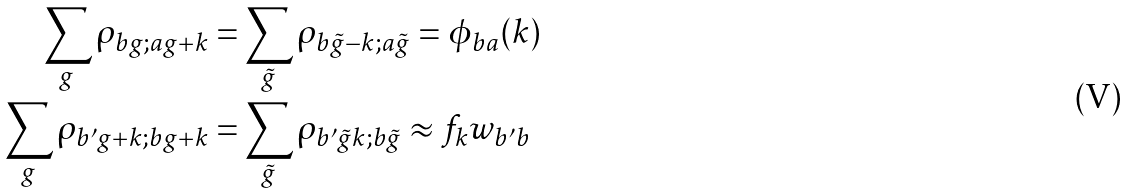<formula> <loc_0><loc_0><loc_500><loc_500>\sum _ { g } \rho _ { b g ; a g + k } = & \sum _ { \tilde { g } } \rho _ { b \tilde { g } - k ; a \tilde { g } } = \phi _ { b a } ( k ) \\ \sum _ { g } \rho _ { b ^ { \prime } g + k ; b g + k } = & \sum _ { \tilde { g } } \rho _ { b ^ { \prime } \tilde { g } k ; b \tilde { g } } \approx f _ { k } w _ { b ^ { \prime } b }</formula> 